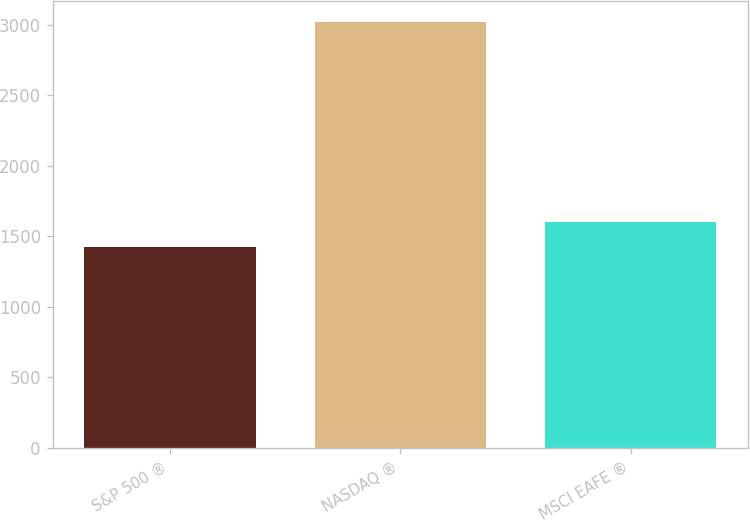Convert chart to OTSL. <chart><loc_0><loc_0><loc_500><loc_500><bar_chart><fcel>S&P 500 ®<fcel>NASDAQ ®<fcel>MSCI EAFE ®<nl><fcel>1426<fcel>3020<fcel>1604<nl></chart> 